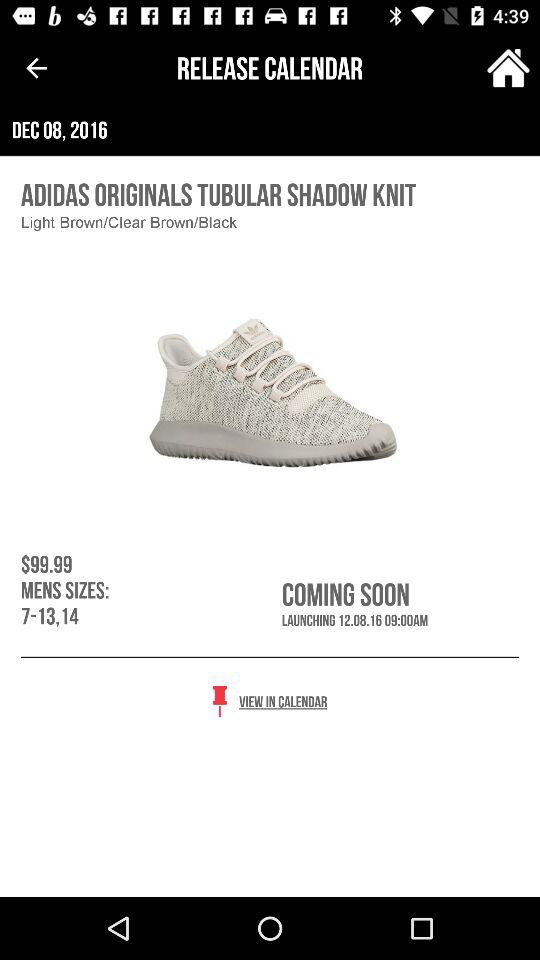What is the cost of the shoes? The cost of the shoes is $99.99. 